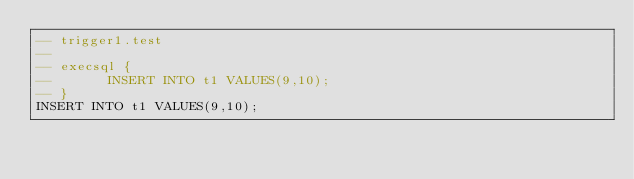Convert code to text. <code><loc_0><loc_0><loc_500><loc_500><_SQL_>-- trigger1.test
-- 
-- execsql {
--       INSERT INTO t1 VALUES(9,10);
-- }
INSERT INTO t1 VALUES(9,10);</code> 